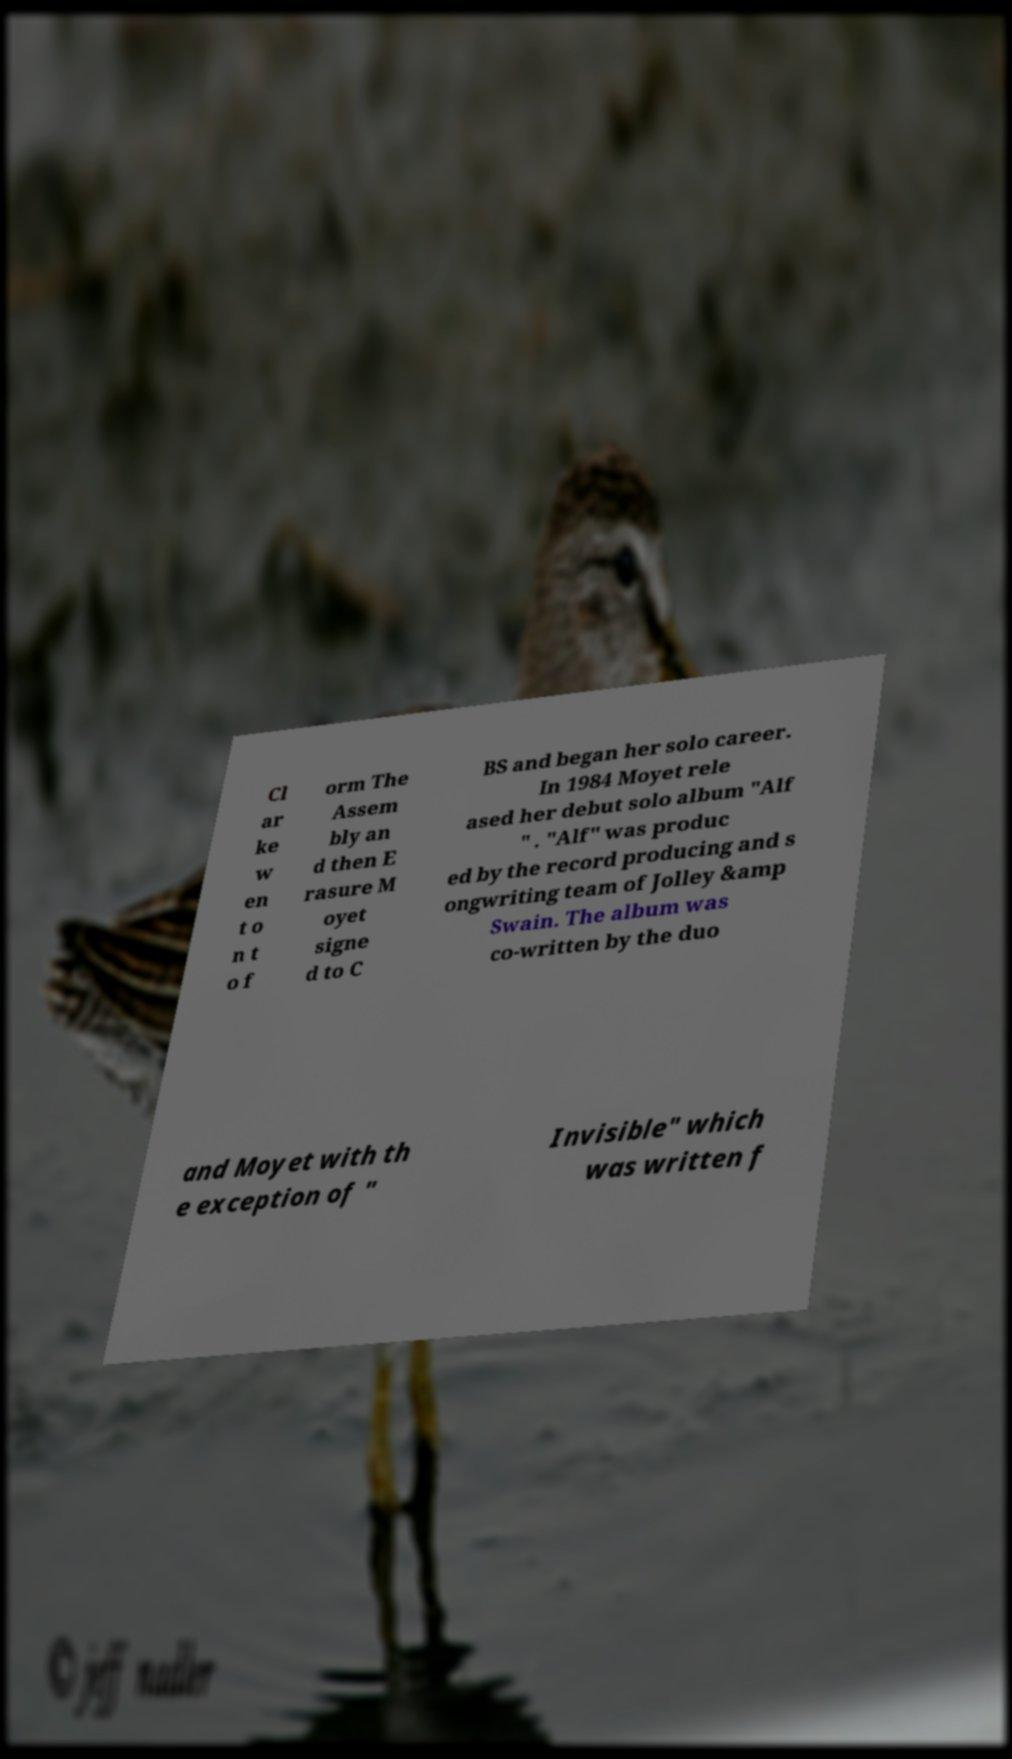Could you extract and type out the text from this image? Cl ar ke w en t o n t o f orm The Assem bly an d then E rasure M oyet signe d to C BS and began her solo career. In 1984 Moyet rele ased her debut solo album "Alf " . "Alf" was produc ed by the record producing and s ongwriting team of Jolley &amp Swain. The album was co-written by the duo and Moyet with th e exception of " Invisible" which was written f 